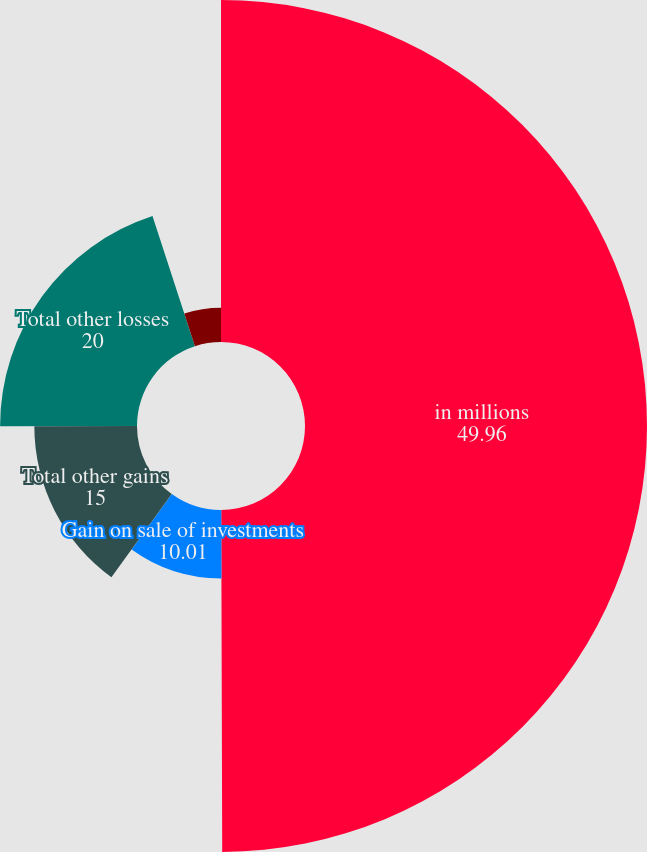<chart> <loc_0><loc_0><loc_500><loc_500><pie_chart><fcel>in millions<fcel>Gain on sale of investments<fcel>Other realized gains<fcel>Total other gains<fcel>Total other losses<fcel>Other gains and losses net<nl><fcel>49.96%<fcel>10.01%<fcel>0.02%<fcel>15.0%<fcel>20.0%<fcel>5.02%<nl></chart> 